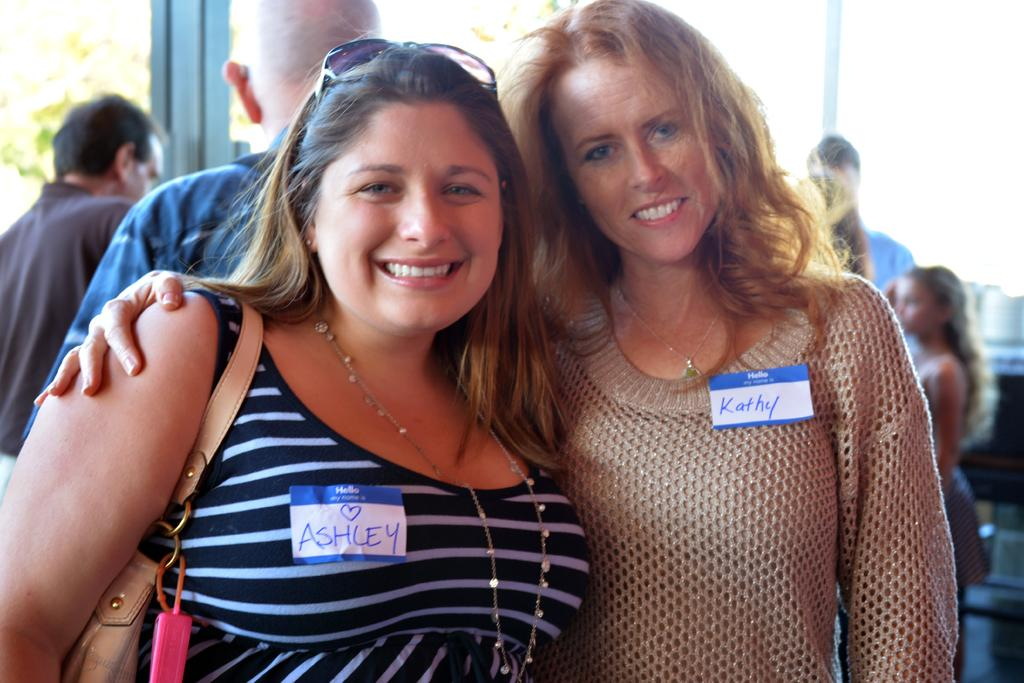How many women are in the image? There are two women in the image. What are the women doing in the image? The women are standing and smiling. Can you describe the background of the image? The background of the image is blurry, but there are people visible. What type of rake is the woman holding in the image? There is no rake present in the image; both women are standing and smiling without any visible objects in their hands. 